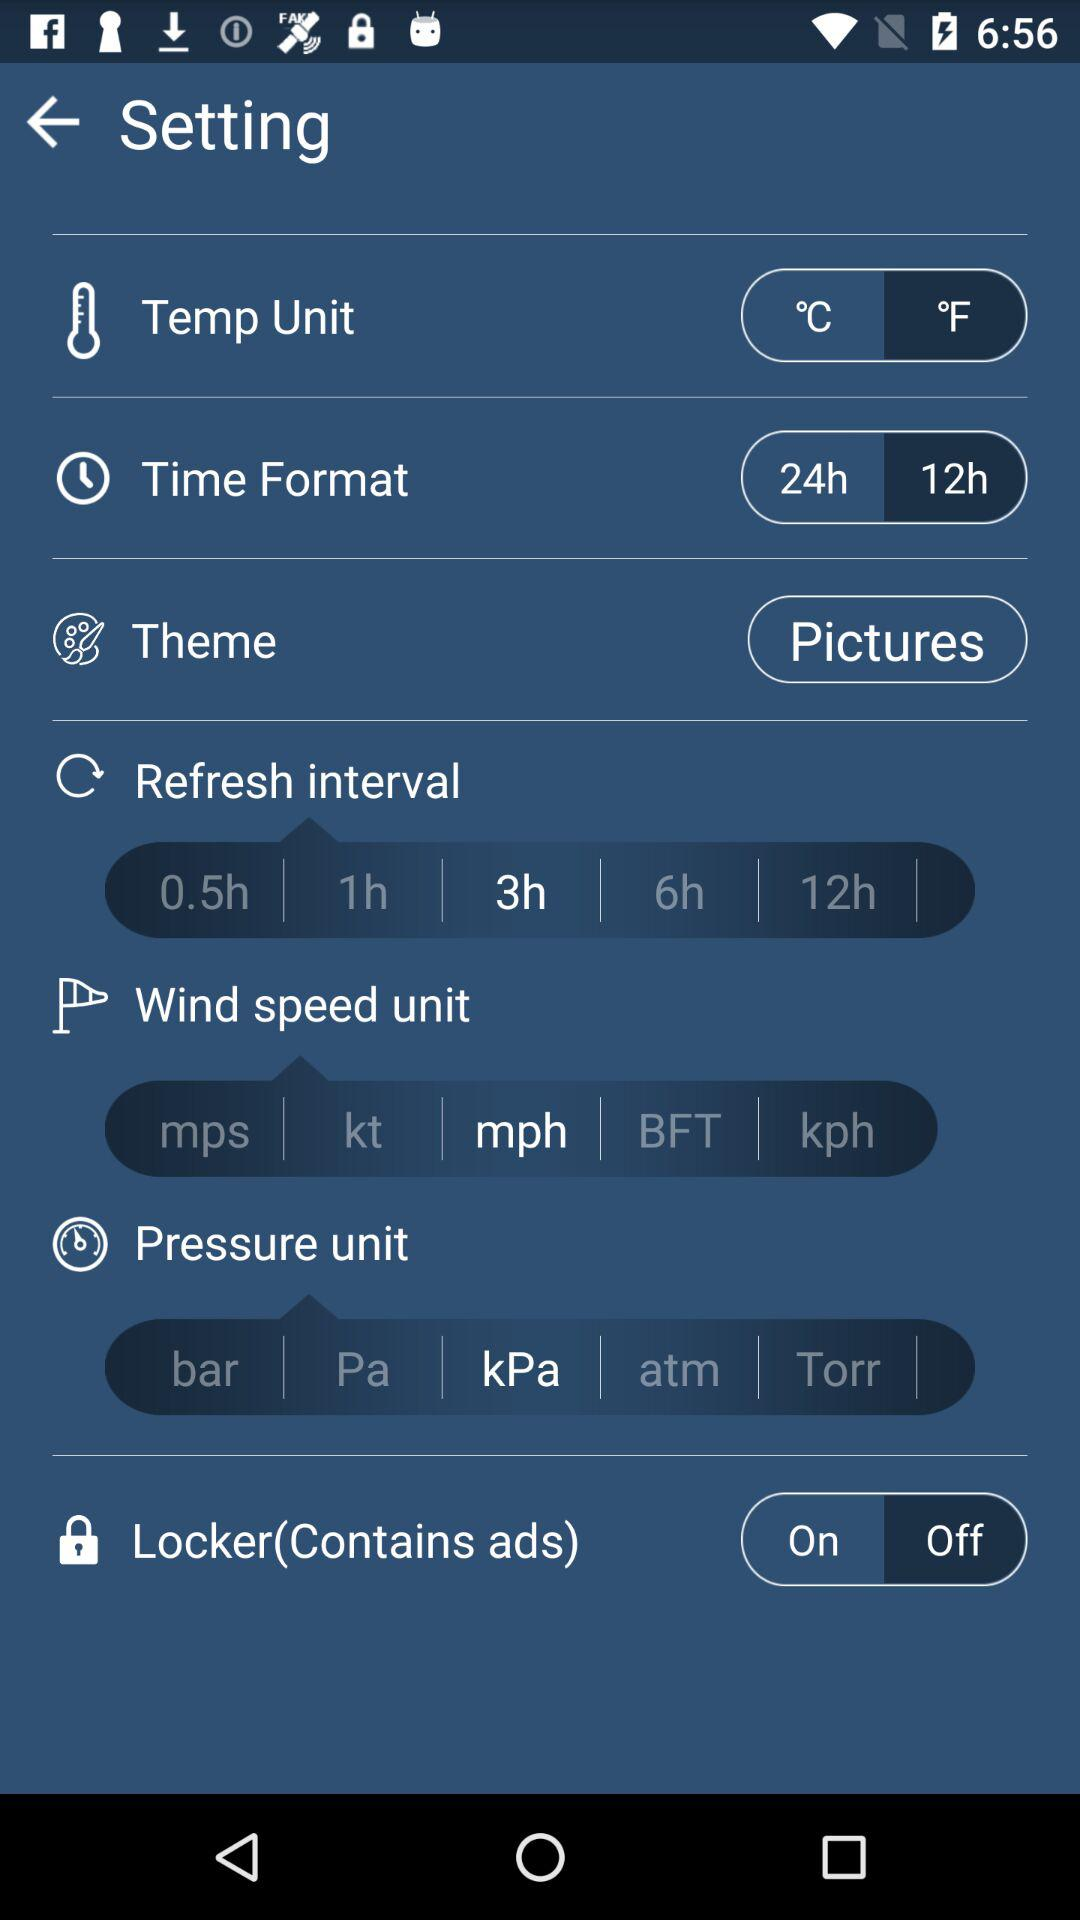What is the refresh interval? The refresh interval is 3 hours. 